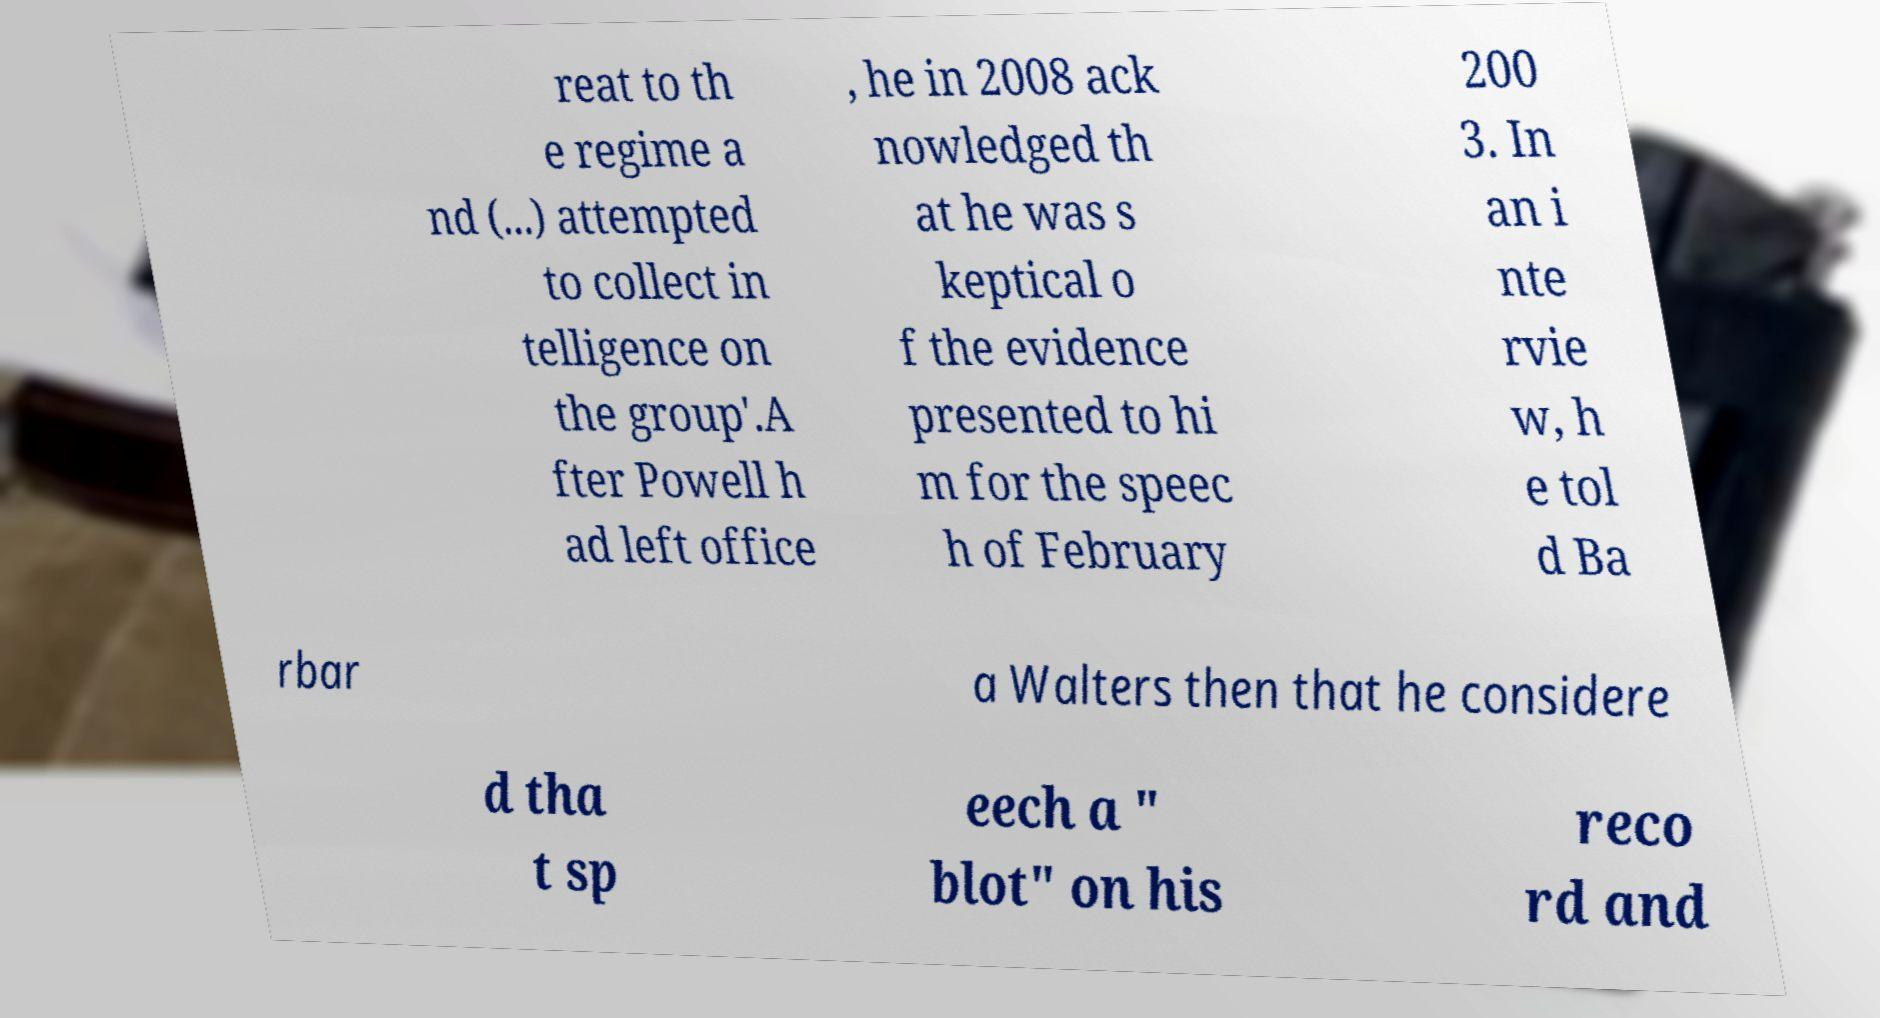What messages or text are displayed in this image? I need them in a readable, typed format. reat to th e regime a nd (...) attempted to collect in telligence on the group'.A fter Powell h ad left office , he in 2008 ack nowledged th at he was s keptical o f the evidence presented to hi m for the speec h of February 200 3. In an i nte rvie w, h e tol d Ba rbar a Walters then that he considere d tha t sp eech a " blot" on his reco rd and 